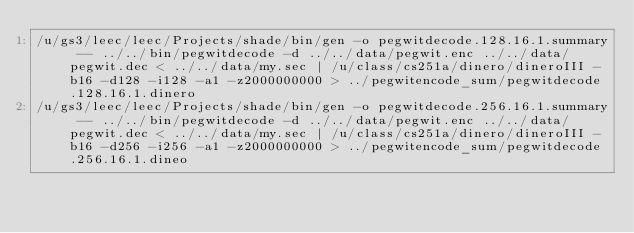Convert code to text. <code><loc_0><loc_0><loc_500><loc_500><_Bash_>/u/gs3/leec/leec/Projects/shade/bin/gen -o pegwitdecode.128.16.1.summary -- ../../bin/pegwitdecode -d ../../data/pegwit.enc ../../data/pegwit.dec < ../../data/my.sec | /u/class/cs251a/dinero/dineroIII -b16 -d128 -i128 -a1 -z2000000000 > ../pegwitencode_sum/pegwitdecode.128.16.1.dinero
/u/gs3/leec/leec/Projects/shade/bin/gen -o pegwitdecode.256.16.1.summary -- ../../bin/pegwitdecode -d ../../data/pegwit.enc ../../data/pegwit.dec < ../../data/my.sec | /u/class/cs251a/dinero/dineroIII -b16 -d256 -i256 -a1 -z2000000000 > ../pegwitencode_sum/pegwitdecode.256.16.1.dineo
</code> 